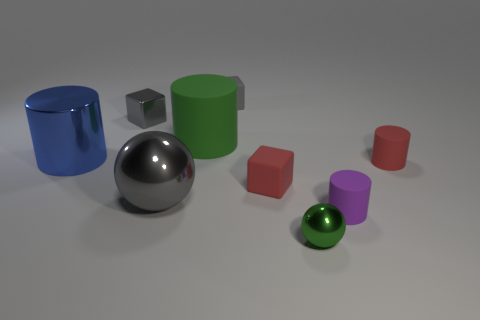How many gray blocks must be subtracted to get 1 gray blocks? 1 Subtract all red blocks. How many blocks are left? 2 Subtract all cylinders. How many objects are left? 5 Subtract 1 cylinders. How many cylinders are left? 3 Subtract all green spheres. How many spheres are left? 1 Subtract all red rubber cylinders. Subtract all shiny spheres. How many objects are left? 6 Add 6 spheres. How many spheres are left? 8 Add 4 brown rubber balls. How many brown rubber balls exist? 4 Add 1 small yellow matte things. How many objects exist? 10 Subtract 0 brown cylinders. How many objects are left? 9 